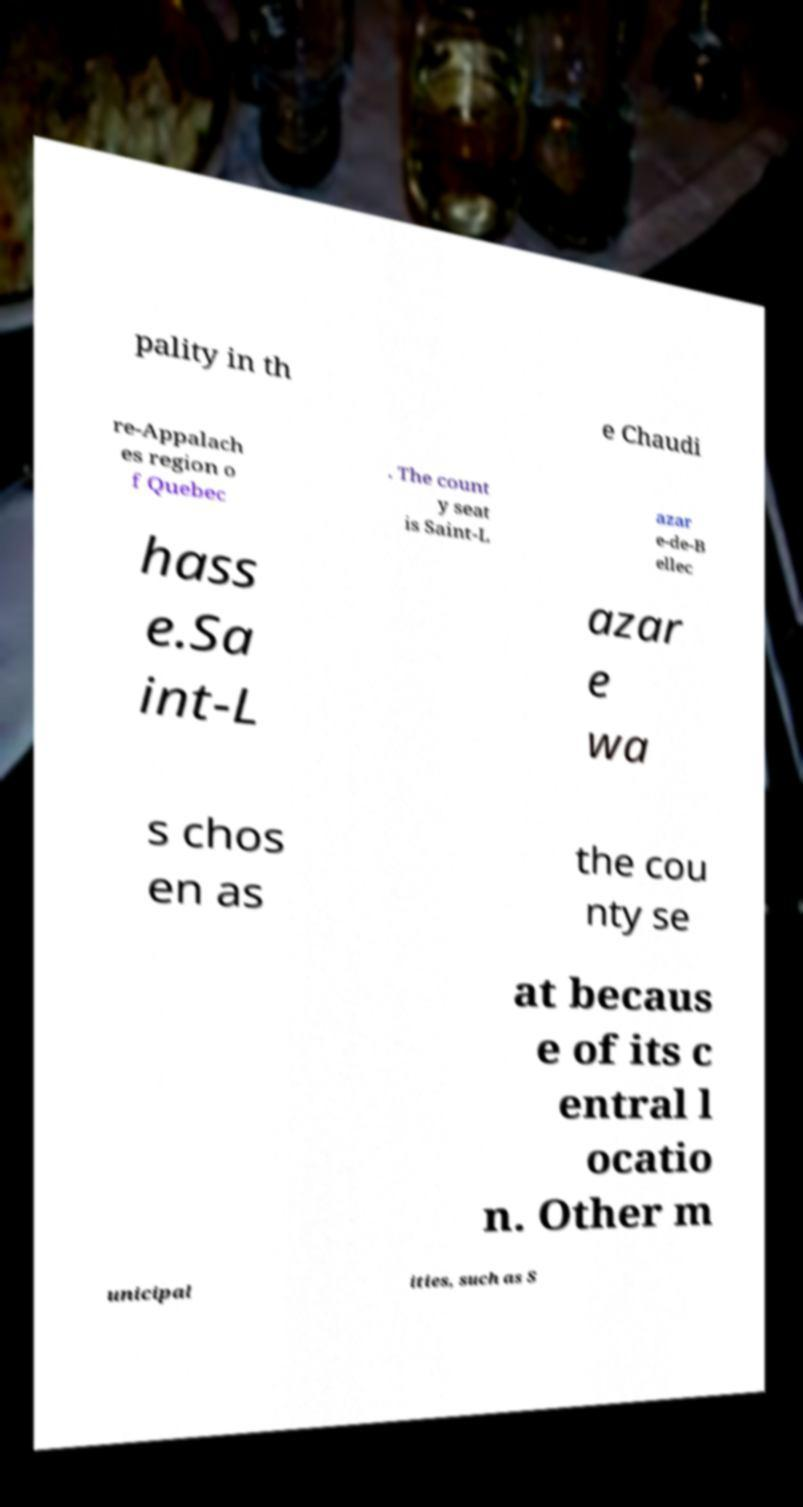Can you read and provide the text displayed in the image?This photo seems to have some interesting text. Can you extract and type it out for me? pality in th e Chaudi re-Appalach es region o f Quebec . The count y seat is Saint-L azar e-de-B ellec hass e.Sa int-L azar e wa s chos en as the cou nty se at becaus e of its c entral l ocatio n. Other m unicipal ities, such as S 